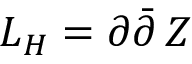<formula> <loc_0><loc_0><loc_500><loc_500>L _ { H } = \partial \bar { \partial } \, Z</formula> 